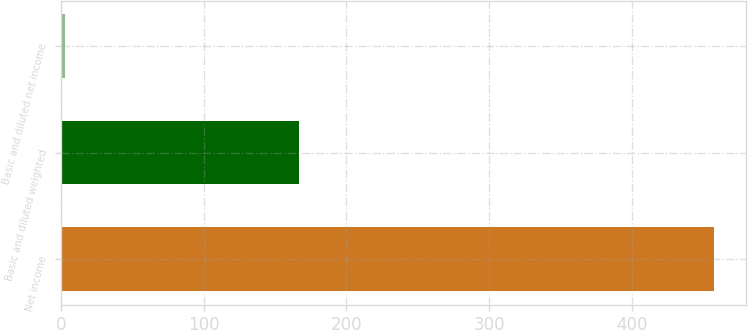Convert chart to OTSL. <chart><loc_0><loc_0><loc_500><loc_500><bar_chart><fcel>Net income<fcel>Basic and diluted weighted<fcel>Basic and diluted net income<nl><fcel>457<fcel>167<fcel>2.74<nl></chart> 